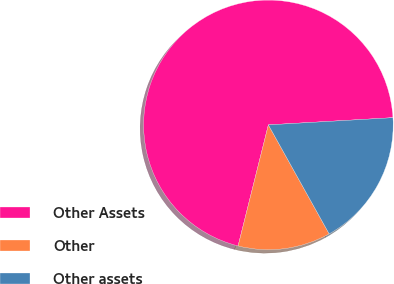<chart> <loc_0><loc_0><loc_500><loc_500><pie_chart><fcel>Other Assets<fcel>Other<fcel>Other assets<nl><fcel>70.18%<fcel>12.0%<fcel>17.82%<nl></chart> 